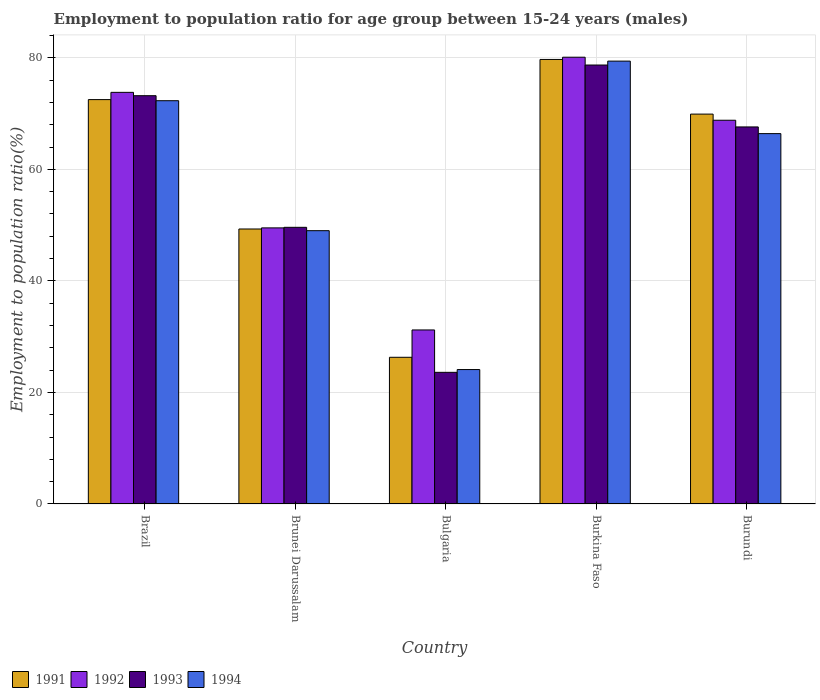Are the number of bars per tick equal to the number of legend labels?
Ensure brevity in your answer.  Yes. Are the number of bars on each tick of the X-axis equal?
Your answer should be compact. Yes. How many bars are there on the 2nd tick from the right?
Offer a very short reply. 4. What is the label of the 2nd group of bars from the left?
Ensure brevity in your answer.  Brunei Darussalam. In how many cases, is the number of bars for a given country not equal to the number of legend labels?
Your answer should be very brief. 0. What is the employment to population ratio in 1994 in Burundi?
Your response must be concise. 66.4. Across all countries, what is the maximum employment to population ratio in 1994?
Keep it short and to the point. 79.4. Across all countries, what is the minimum employment to population ratio in 1994?
Provide a succinct answer. 24.1. In which country was the employment to population ratio in 1992 maximum?
Give a very brief answer. Burkina Faso. What is the total employment to population ratio in 1993 in the graph?
Ensure brevity in your answer.  292.7. What is the difference between the employment to population ratio in 1993 in Bulgaria and that in Burkina Faso?
Make the answer very short. -55.1. What is the difference between the employment to population ratio in 1991 in Burkina Faso and the employment to population ratio in 1993 in Burundi?
Keep it short and to the point. 12.1. What is the average employment to population ratio in 1991 per country?
Make the answer very short. 59.54. What is the difference between the employment to population ratio of/in 1993 and employment to population ratio of/in 1992 in Bulgaria?
Ensure brevity in your answer.  -7.6. In how many countries, is the employment to population ratio in 1991 greater than 20 %?
Your answer should be very brief. 5. What is the ratio of the employment to population ratio in 1991 in Bulgaria to that in Burkina Faso?
Make the answer very short. 0.33. Is the difference between the employment to population ratio in 1993 in Bulgaria and Burundi greater than the difference between the employment to population ratio in 1992 in Bulgaria and Burundi?
Give a very brief answer. No. What is the difference between the highest and the second highest employment to population ratio in 1991?
Make the answer very short. 2.6. What is the difference between the highest and the lowest employment to population ratio in 1993?
Your response must be concise. 55.1. How many bars are there?
Your answer should be compact. 20. Does the graph contain any zero values?
Give a very brief answer. No. Where does the legend appear in the graph?
Provide a short and direct response. Bottom left. How are the legend labels stacked?
Offer a terse response. Horizontal. What is the title of the graph?
Your answer should be compact. Employment to population ratio for age group between 15-24 years (males). Does "1978" appear as one of the legend labels in the graph?
Your response must be concise. No. What is the label or title of the X-axis?
Offer a terse response. Country. What is the label or title of the Y-axis?
Your answer should be compact. Employment to population ratio(%). What is the Employment to population ratio(%) in 1991 in Brazil?
Provide a succinct answer. 72.5. What is the Employment to population ratio(%) of 1992 in Brazil?
Keep it short and to the point. 73.8. What is the Employment to population ratio(%) of 1993 in Brazil?
Provide a short and direct response. 73.2. What is the Employment to population ratio(%) in 1994 in Brazil?
Your response must be concise. 72.3. What is the Employment to population ratio(%) in 1991 in Brunei Darussalam?
Provide a succinct answer. 49.3. What is the Employment to population ratio(%) of 1992 in Brunei Darussalam?
Provide a succinct answer. 49.5. What is the Employment to population ratio(%) of 1993 in Brunei Darussalam?
Your response must be concise. 49.6. What is the Employment to population ratio(%) of 1991 in Bulgaria?
Provide a short and direct response. 26.3. What is the Employment to population ratio(%) of 1992 in Bulgaria?
Provide a short and direct response. 31.2. What is the Employment to population ratio(%) of 1993 in Bulgaria?
Your answer should be very brief. 23.6. What is the Employment to population ratio(%) in 1994 in Bulgaria?
Provide a short and direct response. 24.1. What is the Employment to population ratio(%) in 1991 in Burkina Faso?
Keep it short and to the point. 79.7. What is the Employment to population ratio(%) of 1992 in Burkina Faso?
Provide a short and direct response. 80.1. What is the Employment to population ratio(%) of 1993 in Burkina Faso?
Make the answer very short. 78.7. What is the Employment to population ratio(%) of 1994 in Burkina Faso?
Your answer should be compact. 79.4. What is the Employment to population ratio(%) in 1991 in Burundi?
Give a very brief answer. 69.9. What is the Employment to population ratio(%) of 1992 in Burundi?
Give a very brief answer. 68.8. What is the Employment to population ratio(%) in 1993 in Burundi?
Provide a short and direct response. 67.6. What is the Employment to population ratio(%) of 1994 in Burundi?
Keep it short and to the point. 66.4. Across all countries, what is the maximum Employment to population ratio(%) in 1991?
Your answer should be very brief. 79.7. Across all countries, what is the maximum Employment to population ratio(%) in 1992?
Your response must be concise. 80.1. Across all countries, what is the maximum Employment to population ratio(%) of 1993?
Make the answer very short. 78.7. Across all countries, what is the maximum Employment to population ratio(%) of 1994?
Your answer should be compact. 79.4. Across all countries, what is the minimum Employment to population ratio(%) in 1991?
Offer a terse response. 26.3. Across all countries, what is the minimum Employment to population ratio(%) of 1992?
Provide a short and direct response. 31.2. Across all countries, what is the minimum Employment to population ratio(%) in 1993?
Your answer should be compact. 23.6. Across all countries, what is the minimum Employment to population ratio(%) of 1994?
Offer a very short reply. 24.1. What is the total Employment to population ratio(%) in 1991 in the graph?
Offer a very short reply. 297.7. What is the total Employment to population ratio(%) in 1992 in the graph?
Keep it short and to the point. 303.4. What is the total Employment to population ratio(%) in 1993 in the graph?
Give a very brief answer. 292.7. What is the total Employment to population ratio(%) of 1994 in the graph?
Provide a succinct answer. 291.2. What is the difference between the Employment to population ratio(%) in 1991 in Brazil and that in Brunei Darussalam?
Ensure brevity in your answer.  23.2. What is the difference between the Employment to population ratio(%) of 1992 in Brazil and that in Brunei Darussalam?
Your response must be concise. 24.3. What is the difference between the Employment to population ratio(%) in 1993 in Brazil and that in Brunei Darussalam?
Your answer should be compact. 23.6. What is the difference between the Employment to population ratio(%) in 1994 in Brazil and that in Brunei Darussalam?
Provide a short and direct response. 23.3. What is the difference between the Employment to population ratio(%) of 1991 in Brazil and that in Bulgaria?
Ensure brevity in your answer.  46.2. What is the difference between the Employment to population ratio(%) in 1992 in Brazil and that in Bulgaria?
Make the answer very short. 42.6. What is the difference between the Employment to population ratio(%) of 1993 in Brazil and that in Bulgaria?
Provide a succinct answer. 49.6. What is the difference between the Employment to population ratio(%) of 1994 in Brazil and that in Bulgaria?
Ensure brevity in your answer.  48.2. What is the difference between the Employment to population ratio(%) of 1993 in Brazil and that in Burkina Faso?
Offer a very short reply. -5.5. What is the difference between the Employment to population ratio(%) of 1994 in Brazil and that in Burkina Faso?
Your answer should be compact. -7.1. What is the difference between the Employment to population ratio(%) of 1993 in Brazil and that in Burundi?
Your answer should be compact. 5.6. What is the difference between the Employment to population ratio(%) in 1991 in Brunei Darussalam and that in Bulgaria?
Ensure brevity in your answer.  23. What is the difference between the Employment to population ratio(%) of 1994 in Brunei Darussalam and that in Bulgaria?
Make the answer very short. 24.9. What is the difference between the Employment to population ratio(%) of 1991 in Brunei Darussalam and that in Burkina Faso?
Make the answer very short. -30.4. What is the difference between the Employment to population ratio(%) of 1992 in Brunei Darussalam and that in Burkina Faso?
Your response must be concise. -30.6. What is the difference between the Employment to population ratio(%) of 1993 in Brunei Darussalam and that in Burkina Faso?
Offer a very short reply. -29.1. What is the difference between the Employment to population ratio(%) of 1994 in Brunei Darussalam and that in Burkina Faso?
Provide a succinct answer. -30.4. What is the difference between the Employment to population ratio(%) in 1991 in Brunei Darussalam and that in Burundi?
Give a very brief answer. -20.6. What is the difference between the Employment to population ratio(%) of 1992 in Brunei Darussalam and that in Burundi?
Your answer should be compact. -19.3. What is the difference between the Employment to population ratio(%) of 1994 in Brunei Darussalam and that in Burundi?
Keep it short and to the point. -17.4. What is the difference between the Employment to population ratio(%) in 1991 in Bulgaria and that in Burkina Faso?
Your answer should be compact. -53.4. What is the difference between the Employment to population ratio(%) in 1992 in Bulgaria and that in Burkina Faso?
Your answer should be compact. -48.9. What is the difference between the Employment to population ratio(%) in 1993 in Bulgaria and that in Burkina Faso?
Your response must be concise. -55.1. What is the difference between the Employment to population ratio(%) of 1994 in Bulgaria and that in Burkina Faso?
Provide a short and direct response. -55.3. What is the difference between the Employment to population ratio(%) in 1991 in Bulgaria and that in Burundi?
Offer a terse response. -43.6. What is the difference between the Employment to population ratio(%) in 1992 in Bulgaria and that in Burundi?
Provide a short and direct response. -37.6. What is the difference between the Employment to population ratio(%) in 1993 in Bulgaria and that in Burundi?
Offer a terse response. -44. What is the difference between the Employment to population ratio(%) of 1994 in Bulgaria and that in Burundi?
Keep it short and to the point. -42.3. What is the difference between the Employment to population ratio(%) in 1991 in Brazil and the Employment to population ratio(%) in 1993 in Brunei Darussalam?
Your answer should be very brief. 22.9. What is the difference between the Employment to population ratio(%) in 1992 in Brazil and the Employment to population ratio(%) in 1993 in Brunei Darussalam?
Offer a very short reply. 24.2. What is the difference between the Employment to population ratio(%) in 1992 in Brazil and the Employment to population ratio(%) in 1994 in Brunei Darussalam?
Your response must be concise. 24.8. What is the difference between the Employment to population ratio(%) of 1993 in Brazil and the Employment to population ratio(%) of 1994 in Brunei Darussalam?
Your answer should be compact. 24.2. What is the difference between the Employment to population ratio(%) in 1991 in Brazil and the Employment to population ratio(%) in 1992 in Bulgaria?
Offer a very short reply. 41.3. What is the difference between the Employment to population ratio(%) in 1991 in Brazil and the Employment to population ratio(%) in 1993 in Bulgaria?
Your answer should be very brief. 48.9. What is the difference between the Employment to population ratio(%) in 1991 in Brazil and the Employment to population ratio(%) in 1994 in Bulgaria?
Offer a very short reply. 48.4. What is the difference between the Employment to population ratio(%) in 1992 in Brazil and the Employment to population ratio(%) in 1993 in Bulgaria?
Make the answer very short. 50.2. What is the difference between the Employment to population ratio(%) in 1992 in Brazil and the Employment to population ratio(%) in 1994 in Bulgaria?
Your answer should be very brief. 49.7. What is the difference between the Employment to population ratio(%) of 1993 in Brazil and the Employment to population ratio(%) of 1994 in Bulgaria?
Your answer should be compact. 49.1. What is the difference between the Employment to population ratio(%) in 1991 in Brazil and the Employment to population ratio(%) in 1993 in Burkina Faso?
Offer a terse response. -6.2. What is the difference between the Employment to population ratio(%) of 1992 in Brazil and the Employment to population ratio(%) of 1994 in Burkina Faso?
Your answer should be compact. -5.6. What is the difference between the Employment to population ratio(%) of 1991 in Brazil and the Employment to population ratio(%) of 1993 in Burundi?
Provide a succinct answer. 4.9. What is the difference between the Employment to population ratio(%) in 1991 in Brazil and the Employment to population ratio(%) in 1994 in Burundi?
Provide a short and direct response. 6.1. What is the difference between the Employment to population ratio(%) of 1992 in Brazil and the Employment to population ratio(%) of 1993 in Burundi?
Your answer should be compact. 6.2. What is the difference between the Employment to population ratio(%) of 1993 in Brazil and the Employment to population ratio(%) of 1994 in Burundi?
Your response must be concise. 6.8. What is the difference between the Employment to population ratio(%) of 1991 in Brunei Darussalam and the Employment to population ratio(%) of 1992 in Bulgaria?
Make the answer very short. 18.1. What is the difference between the Employment to population ratio(%) of 1991 in Brunei Darussalam and the Employment to population ratio(%) of 1993 in Bulgaria?
Provide a short and direct response. 25.7. What is the difference between the Employment to population ratio(%) in 1991 in Brunei Darussalam and the Employment to population ratio(%) in 1994 in Bulgaria?
Your answer should be very brief. 25.2. What is the difference between the Employment to population ratio(%) of 1992 in Brunei Darussalam and the Employment to population ratio(%) of 1993 in Bulgaria?
Offer a very short reply. 25.9. What is the difference between the Employment to population ratio(%) of 1992 in Brunei Darussalam and the Employment to population ratio(%) of 1994 in Bulgaria?
Offer a very short reply. 25.4. What is the difference between the Employment to population ratio(%) of 1991 in Brunei Darussalam and the Employment to population ratio(%) of 1992 in Burkina Faso?
Provide a short and direct response. -30.8. What is the difference between the Employment to population ratio(%) of 1991 in Brunei Darussalam and the Employment to population ratio(%) of 1993 in Burkina Faso?
Ensure brevity in your answer.  -29.4. What is the difference between the Employment to population ratio(%) in 1991 in Brunei Darussalam and the Employment to population ratio(%) in 1994 in Burkina Faso?
Offer a very short reply. -30.1. What is the difference between the Employment to population ratio(%) of 1992 in Brunei Darussalam and the Employment to population ratio(%) of 1993 in Burkina Faso?
Your answer should be compact. -29.2. What is the difference between the Employment to population ratio(%) in 1992 in Brunei Darussalam and the Employment to population ratio(%) in 1994 in Burkina Faso?
Your response must be concise. -29.9. What is the difference between the Employment to population ratio(%) in 1993 in Brunei Darussalam and the Employment to population ratio(%) in 1994 in Burkina Faso?
Your answer should be very brief. -29.8. What is the difference between the Employment to population ratio(%) of 1991 in Brunei Darussalam and the Employment to population ratio(%) of 1992 in Burundi?
Ensure brevity in your answer.  -19.5. What is the difference between the Employment to population ratio(%) in 1991 in Brunei Darussalam and the Employment to population ratio(%) in 1993 in Burundi?
Keep it short and to the point. -18.3. What is the difference between the Employment to population ratio(%) of 1991 in Brunei Darussalam and the Employment to population ratio(%) of 1994 in Burundi?
Provide a succinct answer. -17.1. What is the difference between the Employment to population ratio(%) in 1992 in Brunei Darussalam and the Employment to population ratio(%) in 1993 in Burundi?
Keep it short and to the point. -18.1. What is the difference between the Employment to population ratio(%) in 1992 in Brunei Darussalam and the Employment to population ratio(%) in 1994 in Burundi?
Your answer should be compact. -16.9. What is the difference between the Employment to population ratio(%) in 1993 in Brunei Darussalam and the Employment to population ratio(%) in 1994 in Burundi?
Make the answer very short. -16.8. What is the difference between the Employment to population ratio(%) in 1991 in Bulgaria and the Employment to population ratio(%) in 1992 in Burkina Faso?
Your response must be concise. -53.8. What is the difference between the Employment to population ratio(%) in 1991 in Bulgaria and the Employment to population ratio(%) in 1993 in Burkina Faso?
Your answer should be compact. -52.4. What is the difference between the Employment to population ratio(%) in 1991 in Bulgaria and the Employment to population ratio(%) in 1994 in Burkina Faso?
Your response must be concise. -53.1. What is the difference between the Employment to population ratio(%) of 1992 in Bulgaria and the Employment to population ratio(%) of 1993 in Burkina Faso?
Offer a terse response. -47.5. What is the difference between the Employment to population ratio(%) in 1992 in Bulgaria and the Employment to population ratio(%) in 1994 in Burkina Faso?
Provide a succinct answer. -48.2. What is the difference between the Employment to population ratio(%) in 1993 in Bulgaria and the Employment to population ratio(%) in 1994 in Burkina Faso?
Offer a terse response. -55.8. What is the difference between the Employment to population ratio(%) in 1991 in Bulgaria and the Employment to population ratio(%) in 1992 in Burundi?
Make the answer very short. -42.5. What is the difference between the Employment to population ratio(%) of 1991 in Bulgaria and the Employment to population ratio(%) of 1993 in Burundi?
Offer a very short reply. -41.3. What is the difference between the Employment to population ratio(%) of 1991 in Bulgaria and the Employment to population ratio(%) of 1994 in Burundi?
Give a very brief answer. -40.1. What is the difference between the Employment to population ratio(%) in 1992 in Bulgaria and the Employment to population ratio(%) in 1993 in Burundi?
Give a very brief answer. -36.4. What is the difference between the Employment to population ratio(%) of 1992 in Bulgaria and the Employment to population ratio(%) of 1994 in Burundi?
Offer a very short reply. -35.2. What is the difference between the Employment to population ratio(%) of 1993 in Bulgaria and the Employment to population ratio(%) of 1994 in Burundi?
Give a very brief answer. -42.8. What is the difference between the Employment to population ratio(%) in 1992 in Burkina Faso and the Employment to population ratio(%) in 1993 in Burundi?
Provide a succinct answer. 12.5. What is the difference between the Employment to population ratio(%) in 1993 in Burkina Faso and the Employment to population ratio(%) in 1994 in Burundi?
Your response must be concise. 12.3. What is the average Employment to population ratio(%) in 1991 per country?
Make the answer very short. 59.54. What is the average Employment to population ratio(%) of 1992 per country?
Provide a succinct answer. 60.68. What is the average Employment to population ratio(%) in 1993 per country?
Offer a terse response. 58.54. What is the average Employment to population ratio(%) in 1994 per country?
Your answer should be compact. 58.24. What is the difference between the Employment to population ratio(%) in 1991 and Employment to population ratio(%) in 1992 in Brazil?
Provide a short and direct response. -1.3. What is the difference between the Employment to population ratio(%) of 1991 and Employment to population ratio(%) of 1993 in Brazil?
Give a very brief answer. -0.7. What is the difference between the Employment to population ratio(%) in 1991 and Employment to population ratio(%) in 1994 in Brazil?
Offer a very short reply. 0.2. What is the difference between the Employment to population ratio(%) of 1992 and Employment to population ratio(%) of 1994 in Brazil?
Ensure brevity in your answer.  1.5. What is the difference between the Employment to population ratio(%) of 1993 and Employment to population ratio(%) of 1994 in Brazil?
Ensure brevity in your answer.  0.9. What is the difference between the Employment to population ratio(%) of 1991 and Employment to population ratio(%) of 1993 in Brunei Darussalam?
Your answer should be compact. -0.3. What is the difference between the Employment to population ratio(%) in 1991 and Employment to population ratio(%) in 1994 in Bulgaria?
Ensure brevity in your answer.  2.2. What is the difference between the Employment to population ratio(%) in 1992 and Employment to population ratio(%) in 1993 in Bulgaria?
Give a very brief answer. 7.6. What is the difference between the Employment to population ratio(%) of 1992 and Employment to population ratio(%) of 1994 in Bulgaria?
Your response must be concise. 7.1. What is the difference between the Employment to population ratio(%) in 1991 and Employment to population ratio(%) in 1992 in Burkina Faso?
Offer a terse response. -0.4. What is the difference between the Employment to population ratio(%) in 1991 and Employment to population ratio(%) in 1993 in Burkina Faso?
Your answer should be very brief. 1. What is the difference between the Employment to population ratio(%) of 1991 and Employment to population ratio(%) of 1994 in Burkina Faso?
Keep it short and to the point. 0.3. What is the difference between the Employment to population ratio(%) in 1992 and Employment to population ratio(%) in 1994 in Burkina Faso?
Your answer should be compact. 0.7. What is the difference between the Employment to population ratio(%) in 1991 and Employment to population ratio(%) in 1993 in Burundi?
Your answer should be very brief. 2.3. What is the difference between the Employment to population ratio(%) of 1991 and Employment to population ratio(%) of 1994 in Burundi?
Your response must be concise. 3.5. What is the difference between the Employment to population ratio(%) of 1992 and Employment to population ratio(%) of 1993 in Burundi?
Provide a succinct answer. 1.2. What is the difference between the Employment to population ratio(%) in 1992 and Employment to population ratio(%) in 1994 in Burundi?
Ensure brevity in your answer.  2.4. What is the ratio of the Employment to population ratio(%) of 1991 in Brazil to that in Brunei Darussalam?
Your answer should be very brief. 1.47. What is the ratio of the Employment to population ratio(%) of 1992 in Brazil to that in Brunei Darussalam?
Your answer should be very brief. 1.49. What is the ratio of the Employment to population ratio(%) of 1993 in Brazil to that in Brunei Darussalam?
Your answer should be very brief. 1.48. What is the ratio of the Employment to population ratio(%) in 1994 in Brazil to that in Brunei Darussalam?
Offer a very short reply. 1.48. What is the ratio of the Employment to population ratio(%) of 1991 in Brazil to that in Bulgaria?
Offer a very short reply. 2.76. What is the ratio of the Employment to population ratio(%) in 1992 in Brazil to that in Bulgaria?
Your response must be concise. 2.37. What is the ratio of the Employment to population ratio(%) of 1993 in Brazil to that in Bulgaria?
Your answer should be very brief. 3.1. What is the ratio of the Employment to population ratio(%) in 1994 in Brazil to that in Bulgaria?
Offer a terse response. 3. What is the ratio of the Employment to population ratio(%) of 1991 in Brazil to that in Burkina Faso?
Provide a short and direct response. 0.91. What is the ratio of the Employment to population ratio(%) of 1992 in Brazil to that in Burkina Faso?
Give a very brief answer. 0.92. What is the ratio of the Employment to population ratio(%) in 1993 in Brazil to that in Burkina Faso?
Offer a very short reply. 0.93. What is the ratio of the Employment to population ratio(%) of 1994 in Brazil to that in Burkina Faso?
Offer a very short reply. 0.91. What is the ratio of the Employment to population ratio(%) of 1991 in Brazil to that in Burundi?
Give a very brief answer. 1.04. What is the ratio of the Employment to population ratio(%) of 1992 in Brazil to that in Burundi?
Your answer should be very brief. 1.07. What is the ratio of the Employment to population ratio(%) in 1993 in Brazil to that in Burundi?
Give a very brief answer. 1.08. What is the ratio of the Employment to population ratio(%) in 1994 in Brazil to that in Burundi?
Keep it short and to the point. 1.09. What is the ratio of the Employment to population ratio(%) in 1991 in Brunei Darussalam to that in Bulgaria?
Your answer should be very brief. 1.87. What is the ratio of the Employment to population ratio(%) in 1992 in Brunei Darussalam to that in Bulgaria?
Your response must be concise. 1.59. What is the ratio of the Employment to population ratio(%) in 1993 in Brunei Darussalam to that in Bulgaria?
Offer a very short reply. 2.1. What is the ratio of the Employment to population ratio(%) in 1994 in Brunei Darussalam to that in Bulgaria?
Give a very brief answer. 2.03. What is the ratio of the Employment to population ratio(%) in 1991 in Brunei Darussalam to that in Burkina Faso?
Your answer should be very brief. 0.62. What is the ratio of the Employment to population ratio(%) in 1992 in Brunei Darussalam to that in Burkina Faso?
Your answer should be very brief. 0.62. What is the ratio of the Employment to population ratio(%) of 1993 in Brunei Darussalam to that in Burkina Faso?
Make the answer very short. 0.63. What is the ratio of the Employment to population ratio(%) in 1994 in Brunei Darussalam to that in Burkina Faso?
Offer a terse response. 0.62. What is the ratio of the Employment to population ratio(%) of 1991 in Brunei Darussalam to that in Burundi?
Your response must be concise. 0.71. What is the ratio of the Employment to population ratio(%) of 1992 in Brunei Darussalam to that in Burundi?
Keep it short and to the point. 0.72. What is the ratio of the Employment to population ratio(%) of 1993 in Brunei Darussalam to that in Burundi?
Your response must be concise. 0.73. What is the ratio of the Employment to population ratio(%) in 1994 in Brunei Darussalam to that in Burundi?
Offer a very short reply. 0.74. What is the ratio of the Employment to population ratio(%) in 1991 in Bulgaria to that in Burkina Faso?
Offer a very short reply. 0.33. What is the ratio of the Employment to population ratio(%) in 1992 in Bulgaria to that in Burkina Faso?
Keep it short and to the point. 0.39. What is the ratio of the Employment to population ratio(%) of 1993 in Bulgaria to that in Burkina Faso?
Offer a terse response. 0.3. What is the ratio of the Employment to population ratio(%) in 1994 in Bulgaria to that in Burkina Faso?
Keep it short and to the point. 0.3. What is the ratio of the Employment to population ratio(%) of 1991 in Bulgaria to that in Burundi?
Your answer should be compact. 0.38. What is the ratio of the Employment to population ratio(%) in 1992 in Bulgaria to that in Burundi?
Offer a very short reply. 0.45. What is the ratio of the Employment to population ratio(%) in 1993 in Bulgaria to that in Burundi?
Keep it short and to the point. 0.35. What is the ratio of the Employment to population ratio(%) in 1994 in Bulgaria to that in Burundi?
Provide a succinct answer. 0.36. What is the ratio of the Employment to population ratio(%) of 1991 in Burkina Faso to that in Burundi?
Ensure brevity in your answer.  1.14. What is the ratio of the Employment to population ratio(%) in 1992 in Burkina Faso to that in Burundi?
Your answer should be very brief. 1.16. What is the ratio of the Employment to population ratio(%) in 1993 in Burkina Faso to that in Burundi?
Ensure brevity in your answer.  1.16. What is the ratio of the Employment to population ratio(%) in 1994 in Burkina Faso to that in Burundi?
Your answer should be very brief. 1.2. What is the difference between the highest and the second highest Employment to population ratio(%) in 1992?
Provide a succinct answer. 6.3. What is the difference between the highest and the second highest Employment to population ratio(%) of 1994?
Offer a very short reply. 7.1. What is the difference between the highest and the lowest Employment to population ratio(%) of 1991?
Offer a terse response. 53.4. What is the difference between the highest and the lowest Employment to population ratio(%) in 1992?
Offer a very short reply. 48.9. What is the difference between the highest and the lowest Employment to population ratio(%) in 1993?
Your answer should be compact. 55.1. What is the difference between the highest and the lowest Employment to population ratio(%) of 1994?
Give a very brief answer. 55.3. 